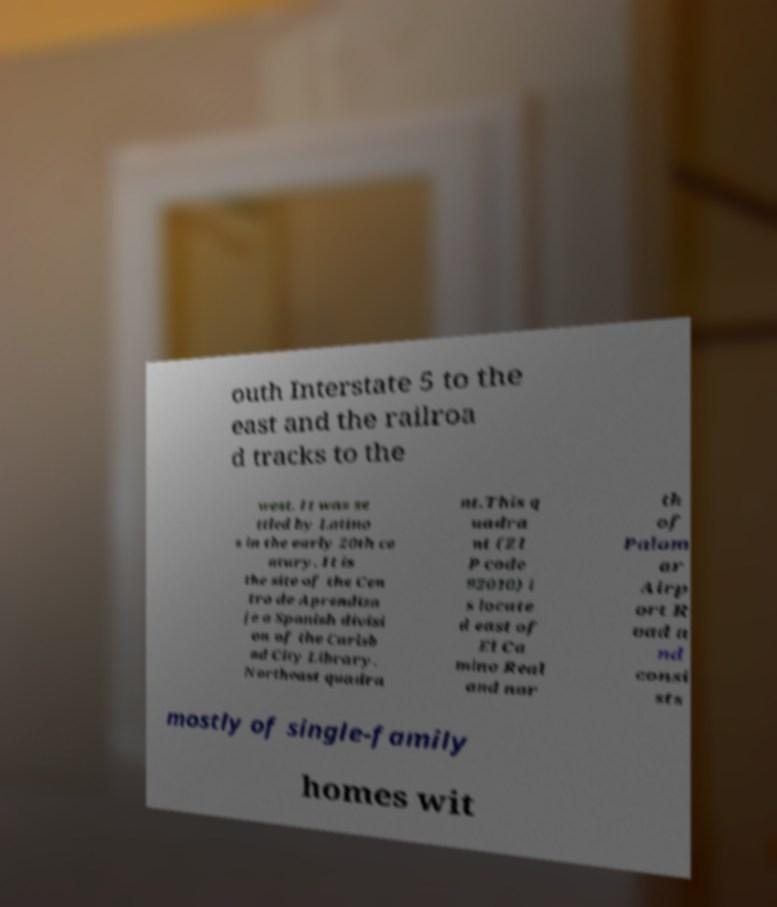Could you assist in decoding the text presented in this image and type it out clearly? outh Interstate 5 to the east and the railroa d tracks to the west. It was se ttled by Latino s in the early 20th ce ntury. It is the site of the Cen tro de Aprendiza je a Spanish divisi on of the Carlsb ad City Library. Northeast quadra nt.This q uadra nt (ZI P code 92010) i s locate d east of El Ca mino Real and nor th of Palom ar Airp ort R oad a nd consi sts mostly of single-family homes wit 